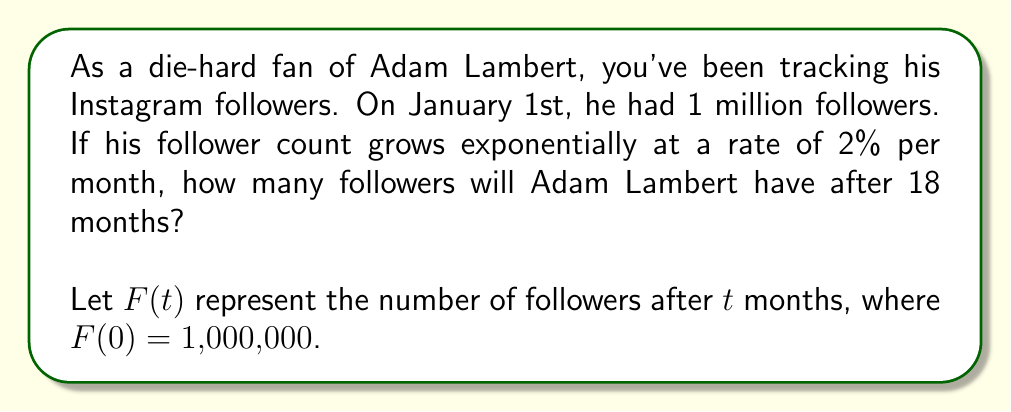Can you solve this math problem? To solve this problem, we'll use the exponential growth formula:

$$F(t) = F(0) \cdot (1 + r)^t$$

Where:
$F(t)$ is the final number of followers
$F(0)$ is the initial number of followers (1,000,000)
$r$ is the growth rate per month (2% = 0.02)
$t$ is the number of months (18)

Let's substitute these values into the formula:

$$F(18) = 1,000,000 \cdot (1 + 0.02)^{18}$$

Now we can calculate:

1. First, calculate $(1 + 0.02)^{18}$:
   $$(1.02)^{18} \approx 1.4281$$

2. Then multiply by the initial number of followers:
   $$1,000,000 \cdot 1.4281 \approx 1,428,100$$

Therefore, after 18 months, Adam Lambert will have approximately 1,428,100 followers.
Answer: $F(18) \approx 1,428,100$ followers 